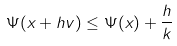Convert formula to latex. <formula><loc_0><loc_0><loc_500><loc_500>\Psi ( x + h v ) \leq \Psi ( x ) + \frac { h } { k }</formula> 